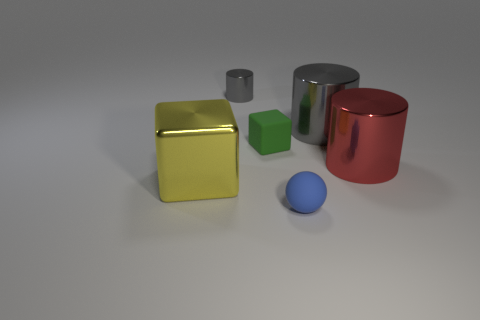Add 1 rubber things. How many objects exist? 7 Subtract all balls. How many objects are left? 5 Subtract all small yellow shiny spheres. Subtract all big gray objects. How many objects are left? 5 Add 3 large red metallic cylinders. How many large red metallic cylinders are left? 4 Add 1 small blue matte things. How many small blue matte things exist? 2 Subtract 2 gray cylinders. How many objects are left? 4 